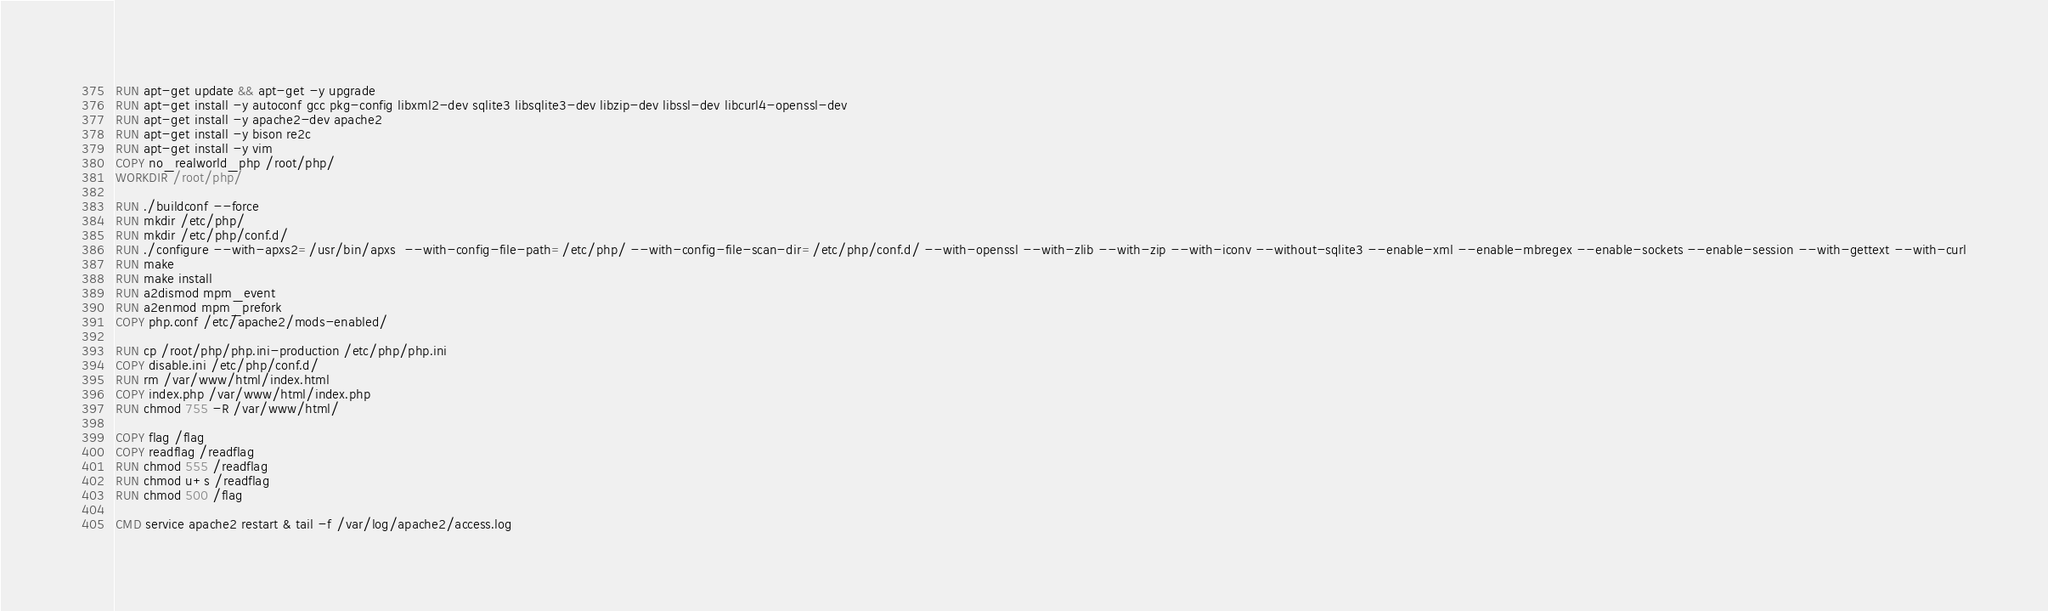Convert code to text. <code><loc_0><loc_0><loc_500><loc_500><_Dockerfile_>
RUN apt-get update && apt-get -y upgrade
RUN apt-get install -y autoconf gcc pkg-config libxml2-dev sqlite3 libsqlite3-dev libzip-dev libssl-dev libcurl4-openssl-dev
RUN apt-get install -y apache2-dev apache2
RUN apt-get install -y bison re2c
RUN apt-get install -y vim
COPY no_realworld_php /root/php/
WORKDIR /root/php/

RUN ./buildconf --force
RUN mkdir /etc/php/
RUN mkdir /etc/php/conf.d/
RUN ./configure --with-apxs2=/usr/bin/apxs  --with-config-file-path=/etc/php/ --with-config-file-scan-dir=/etc/php/conf.d/ --with-openssl --with-zlib --with-zip --with-iconv --without-sqlite3 --enable-xml --enable-mbregex --enable-sockets --enable-session --with-gettext --with-curl
RUN make
RUN make install
RUN a2dismod mpm_event
RUN a2enmod mpm_prefork
COPY php.conf /etc/apache2/mods-enabled/

RUN cp /root/php/php.ini-production /etc/php/php.ini
COPY disable.ini /etc/php/conf.d/
RUN rm /var/www/html/index.html
COPY index.php /var/www/html/index.php
RUN chmod 755 -R /var/www/html/

COPY flag /flag
COPY readflag /readflag
RUN chmod 555 /readflag
RUN chmod u+s /readflag
RUN chmod 500 /flag

CMD service apache2 restart & tail -f /var/log/apache2/access.log
</code> 